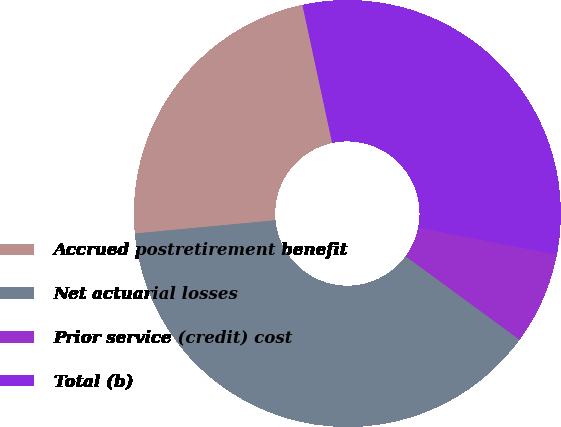<chart> <loc_0><loc_0><loc_500><loc_500><pie_chart><fcel>Accrued postretirement benefit<fcel>Net actuarial losses<fcel>Prior service (credit) cost<fcel>Total (b)<nl><fcel>23.12%<fcel>38.44%<fcel>6.98%<fcel>31.46%<nl></chart> 